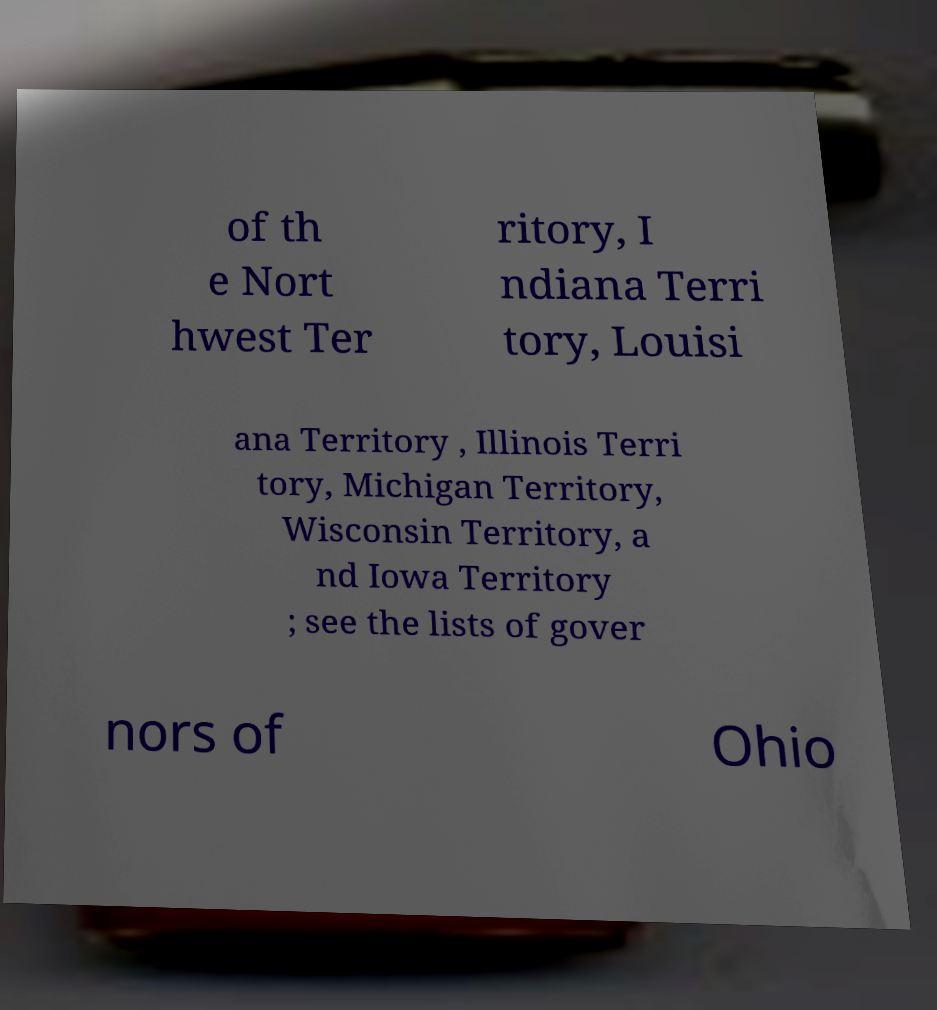Can you read and provide the text displayed in the image?This photo seems to have some interesting text. Can you extract and type it out for me? of th e Nort hwest Ter ritory, I ndiana Terri tory, Louisi ana Territory , Illinois Terri tory, Michigan Territory, Wisconsin Territory, a nd Iowa Territory ; see the lists of gover nors of Ohio 